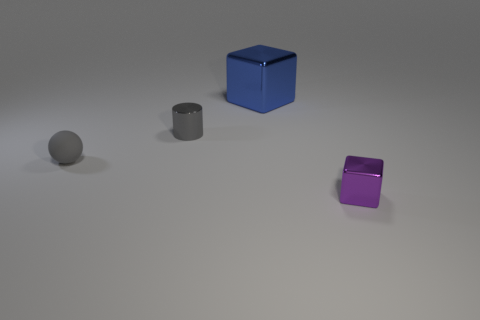There is a purple thing that is the same size as the metal cylinder; what is its material?
Your response must be concise. Metal. How many things are either shiny things that are in front of the gray shiny cylinder or big blocks?
Ensure brevity in your answer.  2. Are there the same number of blocks that are left of the small metallic cylinder and cyan metal cylinders?
Offer a very short reply. Yes. Do the small rubber ball and the small shiny cylinder have the same color?
Provide a succinct answer. Yes. There is a metal thing that is in front of the big metal thing and behind the tiny ball; what is its color?
Offer a terse response. Gray. What number of cubes are tiny objects or big things?
Your answer should be compact. 2. Are there fewer purple cubes on the left side of the big metallic thing than tiny cubes?
Keep it short and to the point. Yes. What shape is the tiny purple object that is made of the same material as the big blue block?
Make the answer very short. Cube. How many cylinders are the same color as the small rubber thing?
Your answer should be compact. 1. What number of things are tiny objects or blue cubes?
Your answer should be very brief. 4. 